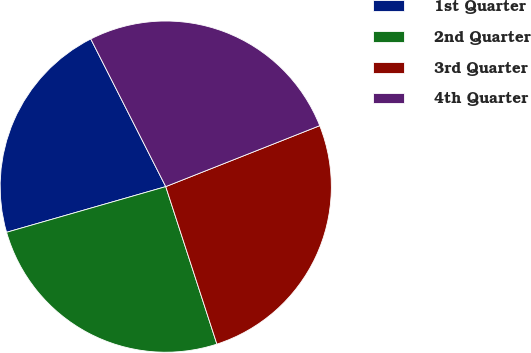Convert chart. <chart><loc_0><loc_0><loc_500><loc_500><pie_chart><fcel>1st Quarter<fcel>2nd Quarter<fcel>3rd Quarter<fcel>4th Quarter<nl><fcel>21.97%<fcel>25.55%<fcel>26.0%<fcel>26.48%<nl></chart> 